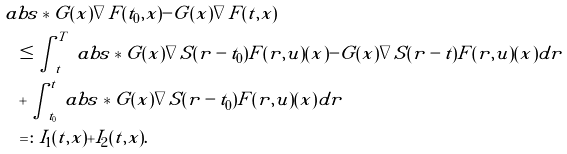Convert formula to latex. <formula><loc_0><loc_0><loc_500><loc_500>& \ a b s * { G ( x ) \nabla \tilde { F } ( t _ { 0 } , x ) - G ( x ) \nabla \tilde { F } ( t , x ) } \\ & \quad \leq \int _ { t } ^ { T } \ a b s * { G ( x ) \nabla S ( r - t _ { 0 } ) F ( r , u ) ( x ) - G ( x ) \nabla S ( r - t ) F ( r , u ) ( x ) } d r \\ & \quad + \int _ { t _ { 0 } } ^ { t } \ a b s * { G ( x ) \nabla S ( r - t _ { 0 } ) F ( r , u ) ( x ) } d r \\ & \quad = \colon \tilde { I } _ { 1 } ( t , x ) + \tilde { I } _ { 2 } ( t , x ) .</formula> 